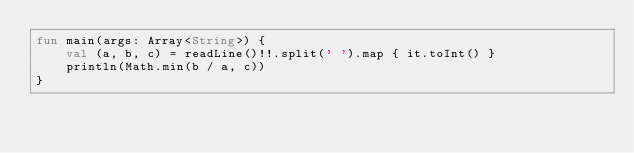Convert code to text. <code><loc_0><loc_0><loc_500><loc_500><_Kotlin_>fun main(args: Array<String>) {
    val (a, b, c) = readLine()!!.split(' ').map { it.toInt() }
    println(Math.min(b / a, c))
}</code> 